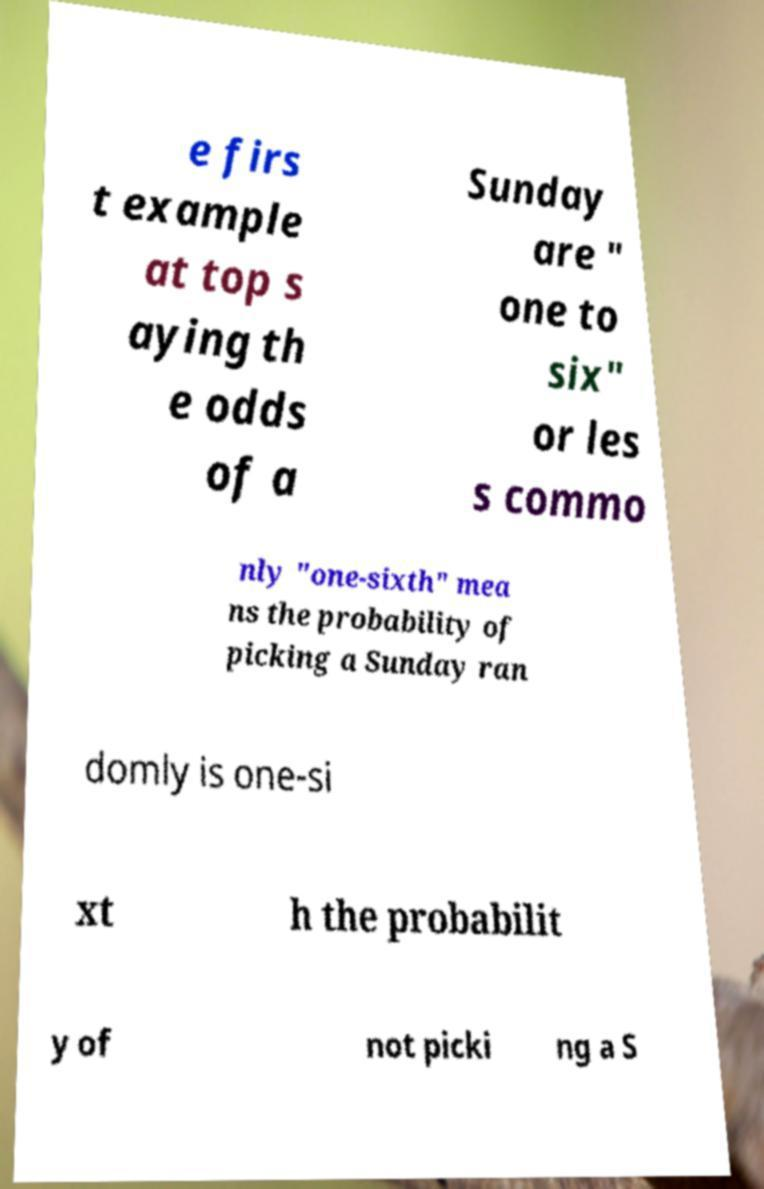What messages or text are displayed in this image? I need them in a readable, typed format. e firs t example at top s aying th e odds of a Sunday are " one to six" or les s commo nly "one-sixth" mea ns the probability of picking a Sunday ran domly is one-si xt h the probabilit y of not picki ng a S 